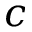Convert formula to latex. <formula><loc_0><loc_0><loc_500><loc_500>c</formula> 